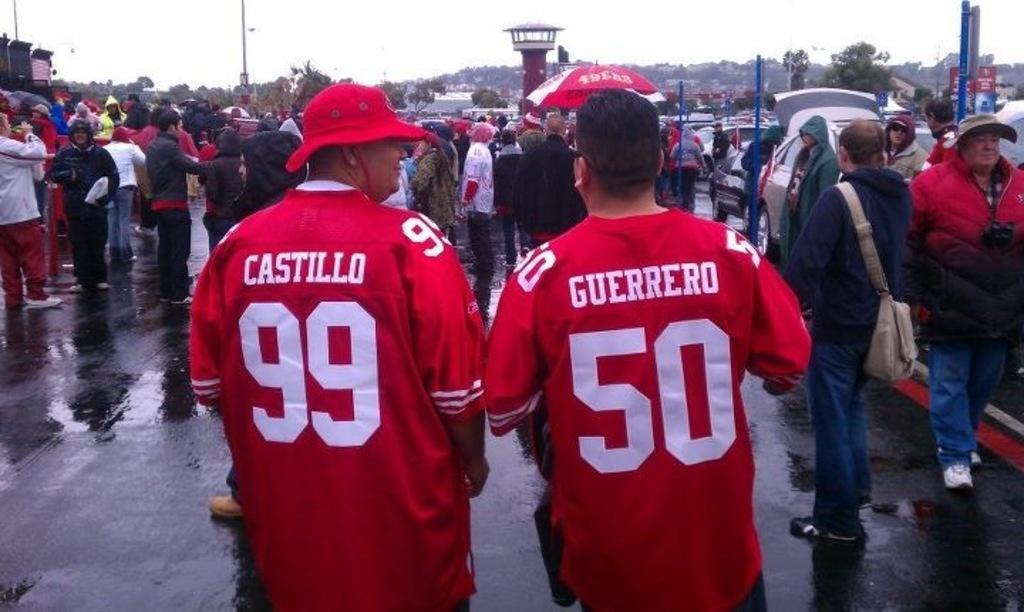<image>
Share a concise interpretation of the image provided. Two people wearing red sports jerseys walk with a crowd in the rain. 